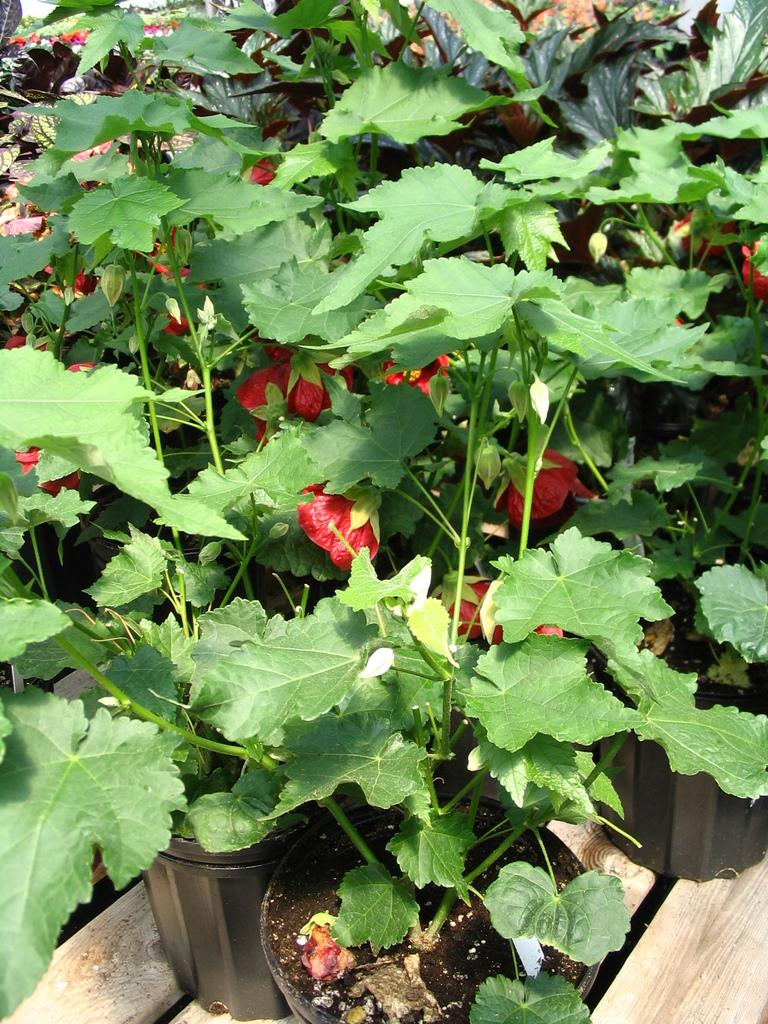What type of living organisms can be seen in the image? Plants and flowers are visible in the image. Can you describe the flowers in the image? The flowers in the image are part of the plants and add color and beauty to the scene. What type of band is performing in the image? There is no band present in the image; it features plants and flowers. What action is causing the plants to grow in the image? The image does not show any specific action causing the plants to grow; it simply depicts them in their current state. 